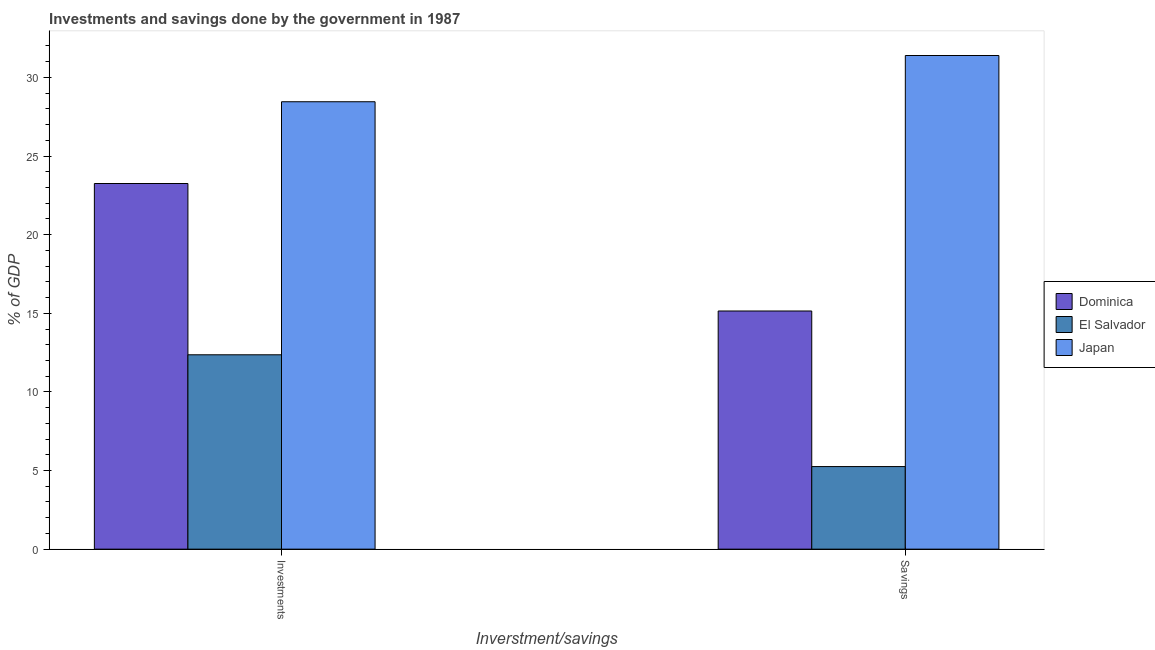How many groups of bars are there?
Ensure brevity in your answer.  2. Are the number of bars per tick equal to the number of legend labels?
Offer a very short reply. Yes. How many bars are there on the 2nd tick from the left?
Provide a succinct answer. 3. What is the label of the 2nd group of bars from the left?
Give a very brief answer. Savings. What is the savings of government in Dominica?
Ensure brevity in your answer.  15.15. Across all countries, what is the maximum investments of government?
Give a very brief answer. 28.45. Across all countries, what is the minimum investments of government?
Give a very brief answer. 12.36. In which country was the savings of government minimum?
Give a very brief answer. El Salvador. What is the total investments of government in the graph?
Make the answer very short. 64.07. What is the difference between the savings of government in Dominica and that in Japan?
Keep it short and to the point. -16.25. What is the difference between the investments of government in El Salvador and the savings of government in Dominica?
Your response must be concise. -2.78. What is the average investments of government per country?
Your answer should be very brief. 21.36. What is the difference between the investments of government and savings of government in Japan?
Your response must be concise. -2.94. In how many countries, is the savings of government greater than 26 %?
Your answer should be compact. 1. What is the ratio of the investments of government in Japan to that in El Salvador?
Keep it short and to the point. 2.3. Is the savings of government in Japan less than that in Dominica?
Make the answer very short. No. In how many countries, is the savings of government greater than the average savings of government taken over all countries?
Give a very brief answer. 1. What does the 1st bar from the left in Savings represents?
Provide a succinct answer. Dominica. Are all the bars in the graph horizontal?
Offer a terse response. No. What is the difference between two consecutive major ticks on the Y-axis?
Offer a terse response. 5. Are the values on the major ticks of Y-axis written in scientific E-notation?
Offer a very short reply. No. Does the graph contain any zero values?
Provide a short and direct response. No. How many legend labels are there?
Keep it short and to the point. 3. What is the title of the graph?
Your answer should be compact. Investments and savings done by the government in 1987. Does "Philippines" appear as one of the legend labels in the graph?
Your response must be concise. No. What is the label or title of the X-axis?
Ensure brevity in your answer.  Inverstment/savings. What is the label or title of the Y-axis?
Your answer should be very brief. % of GDP. What is the % of GDP of Dominica in Investments?
Your answer should be compact. 23.25. What is the % of GDP in El Salvador in Investments?
Your answer should be very brief. 12.36. What is the % of GDP of Japan in Investments?
Your answer should be compact. 28.45. What is the % of GDP of Dominica in Savings?
Keep it short and to the point. 15.15. What is the % of GDP in El Salvador in Savings?
Your answer should be very brief. 5.25. What is the % of GDP of Japan in Savings?
Your answer should be very brief. 31.39. Across all Inverstment/savings, what is the maximum % of GDP in Dominica?
Offer a terse response. 23.25. Across all Inverstment/savings, what is the maximum % of GDP in El Salvador?
Your answer should be very brief. 12.36. Across all Inverstment/savings, what is the maximum % of GDP of Japan?
Your answer should be compact. 31.39. Across all Inverstment/savings, what is the minimum % of GDP in Dominica?
Your response must be concise. 15.15. Across all Inverstment/savings, what is the minimum % of GDP in El Salvador?
Keep it short and to the point. 5.25. Across all Inverstment/savings, what is the minimum % of GDP of Japan?
Your response must be concise. 28.45. What is the total % of GDP in Dominica in the graph?
Keep it short and to the point. 38.4. What is the total % of GDP in El Salvador in the graph?
Offer a very short reply. 17.61. What is the total % of GDP in Japan in the graph?
Provide a short and direct response. 59.85. What is the difference between the % of GDP in Dominica in Investments and that in Savings?
Your response must be concise. 8.11. What is the difference between the % of GDP in El Salvador in Investments and that in Savings?
Offer a very short reply. 7.11. What is the difference between the % of GDP of Japan in Investments and that in Savings?
Offer a terse response. -2.94. What is the difference between the % of GDP of Dominica in Investments and the % of GDP of El Salvador in Savings?
Your answer should be very brief. 18. What is the difference between the % of GDP in Dominica in Investments and the % of GDP in Japan in Savings?
Make the answer very short. -8.14. What is the difference between the % of GDP of El Salvador in Investments and the % of GDP of Japan in Savings?
Your answer should be very brief. -19.03. What is the average % of GDP in Dominica per Inverstment/savings?
Your answer should be compact. 19.2. What is the average % of GDP in El Salvador per Inverstment/savings?
Offer a very short reply. 8.81. What is the average % of GDP in Japan per Inverstment/savings?
Provide a short and direct response. 29.92. What is the difference between the % of GDP of Dominica and % of GDP of El Salvador in Investments?
Make the answer very short. 10.89. What is the difference between the % of GDP in Dominica and % of GDP in Japan in Investments?
Give a very brief answer. -5.2. What is the difference between the % of GDP of El Salvador and % of GDP of Japan in Investments?
Your answer should be compact. -16.09. What is the difference between the % of GDP of Dominica and % of GDP of El Salvador in Savings?
Offer a very short reply. 9.89. What is the difference between the % of GDP in Dominica and % of GDP in Japan in Savings?
Make the answer very short. -16.25. What is the difference between the % of GDP in El Salvador and % of GDP in Japan in Savings?
Keep it short and to the point. -26.14. What is the ratio of the % of GDP of Dominica in Investments to that in Savings?
Your answer should be compact. 1.54. What is the ratio of the % of GDP in El Salvador in Investments to that in Savings?
Ensure brevity in your answer.  2.35. What is the ratio of the % of GDP in Japan in Investments to that in Savings?
Give a very brief answer. 0.91. What is the difference between the highest and the second highest % of GDP in Dominica?
Provide a succinct answer. 8.11. What is the difference between the highest and the second highest % of GDP in El Salvador?
Provide a short and direct response. 7.11. What is the difference between the highest and the second highest % of GDP of Japan?
Provide a succinct answer. 2.94. What is the difference between the highest and the lowest % of GDP of Dominica?
Offer a terse response. 8.11. What is the difference between the highest and the lowest % of GDP in El Salvador?
Your answer should be very brief. 7.11. What is the difference between the highest and the lowest % of GDP of Japan?
Provide a short and direct response. 2.94. 